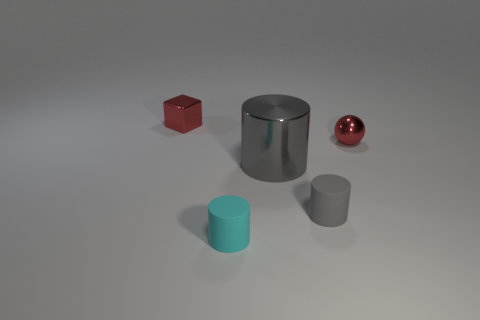Add 1 red blocks. How many objects exist? 6 Subtract all spheres. How many objects are left? 4 Subtract 0 gray cubes. How many objects are left? 5 Subtract all small metal objects. Subtract all big gray cylinders. How many objects are left? 2 Add 4 gray metal things. How many gray metal things are left? 5 Add 5 gray things. How many gray things exist? 7 